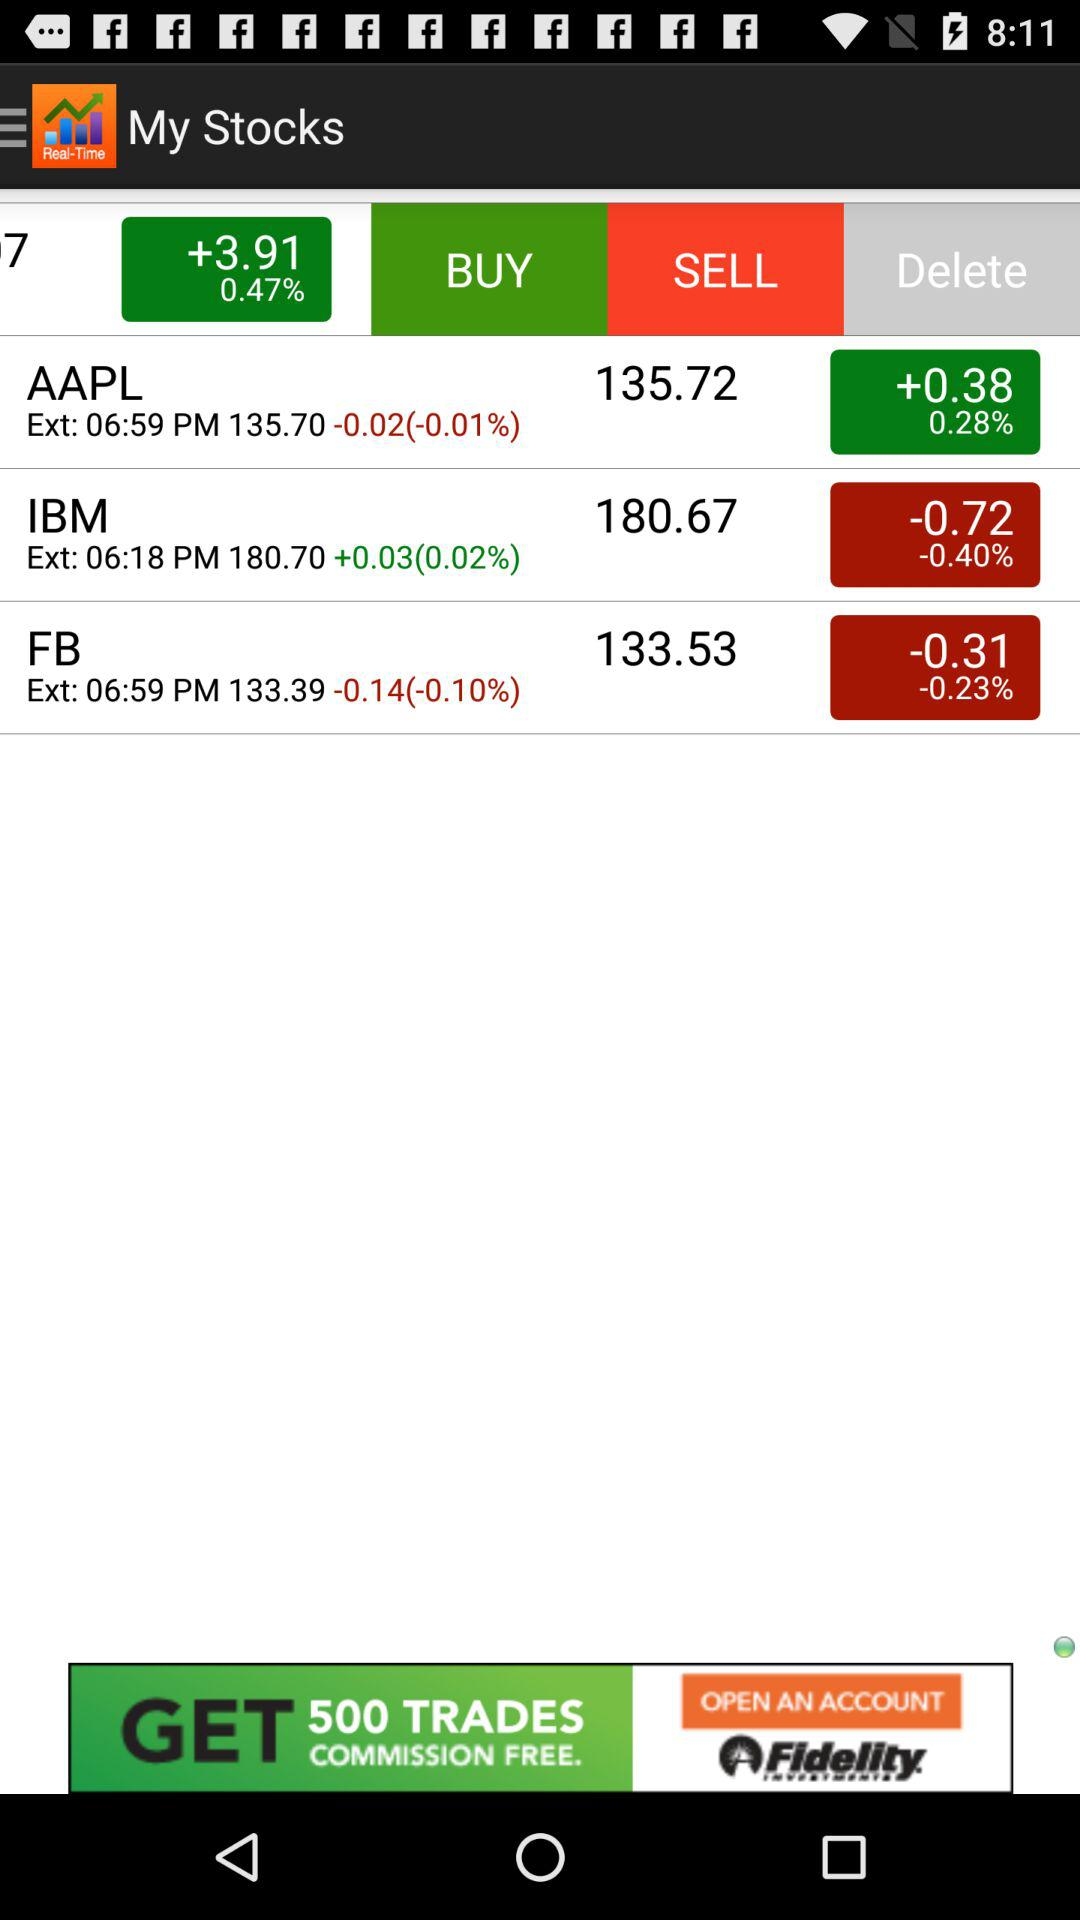What is the percentage change in price of FB?
Answer the question using a single word or phrase. -0.10% 